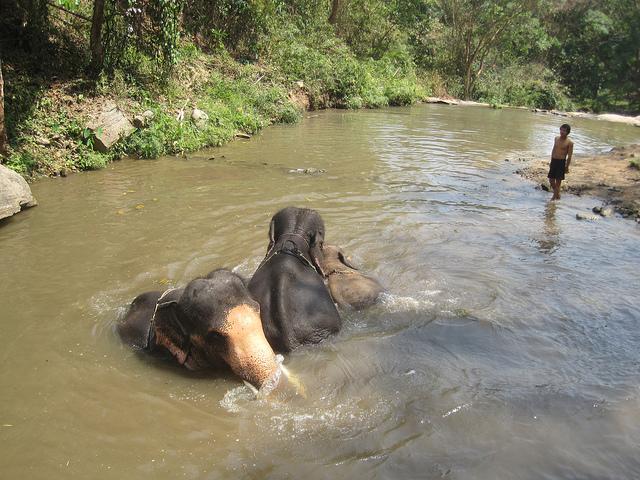Is the water very clean?
Answer briefly. No. What continent is this animal native to?
Concise answer only. Africa. Are there 3 elephants taking a bath?
Write a very short answer. Yes. What is the animal laying on?
Quick response, please. Water. What animal is shown in the water?
Concise answer only. Elephant. What is the person in the picture wearing?
Be succinct. Shorts. Are these both the same animal?
Concise answer only. Yes. What animal is swimming?
Concise answer only. Elephant. What kind of animal is this?
Answer briefly. Elephant. 